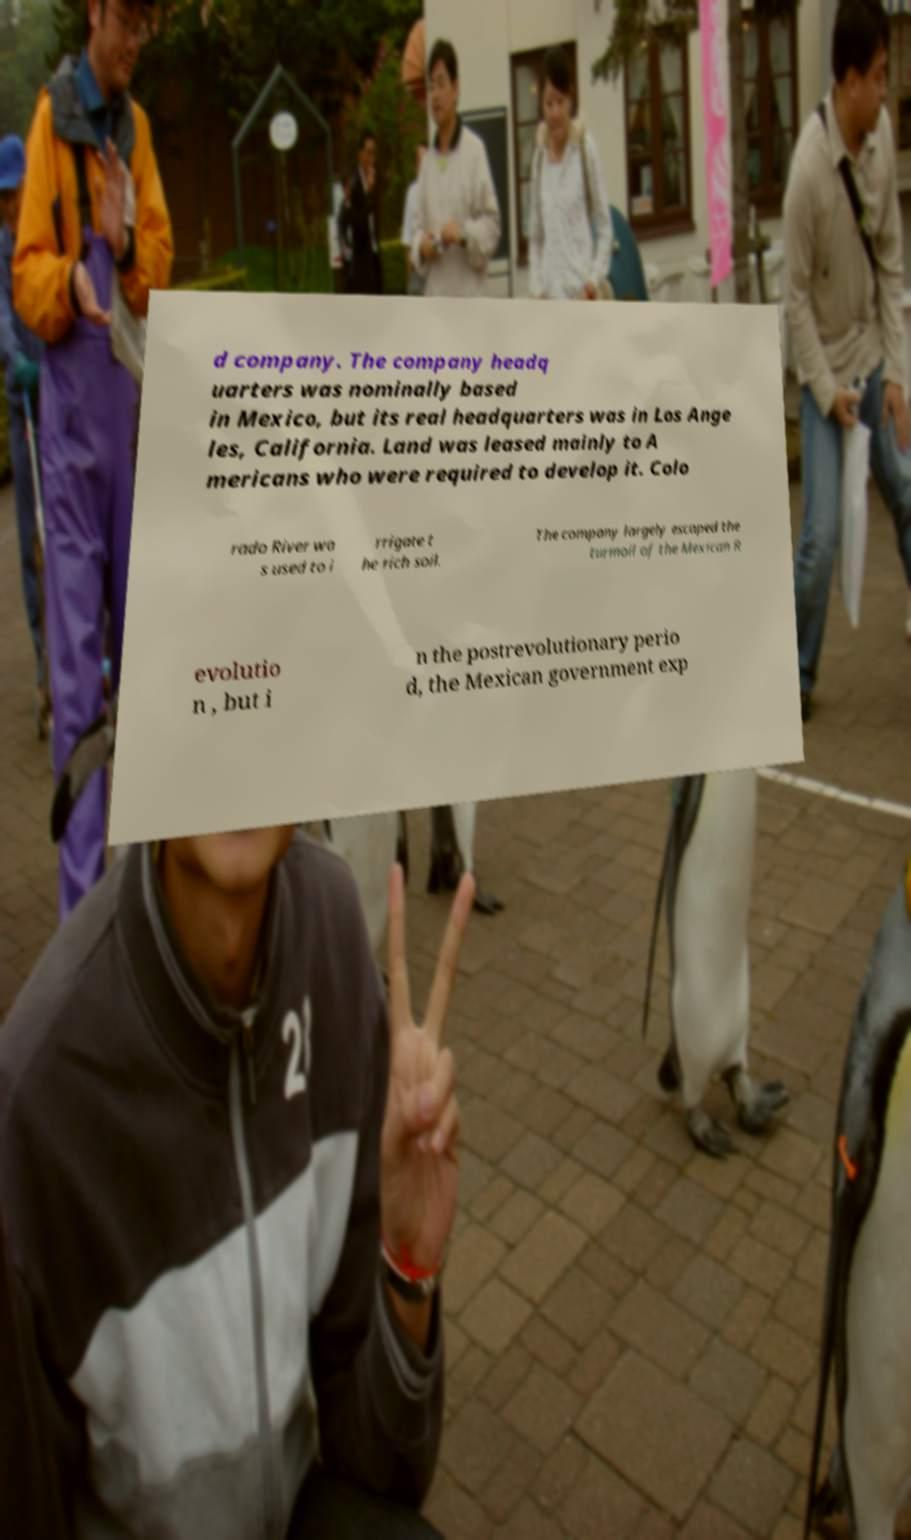For documentation purposes, I need the text within this image transcribed. Could you provide that? d company. The company headq uarters was nominally based in Mexico, but its real headquarters was in Los Ange les, California. Land was leased mainly to A mericans who were required to develop it. Colo rado River wa s used to i rrigate t he rich soil. The company largely escaped the turmoil of the Mexican R evolutio n , but i n the postrevolutionary perio d, the Mexican government exp 